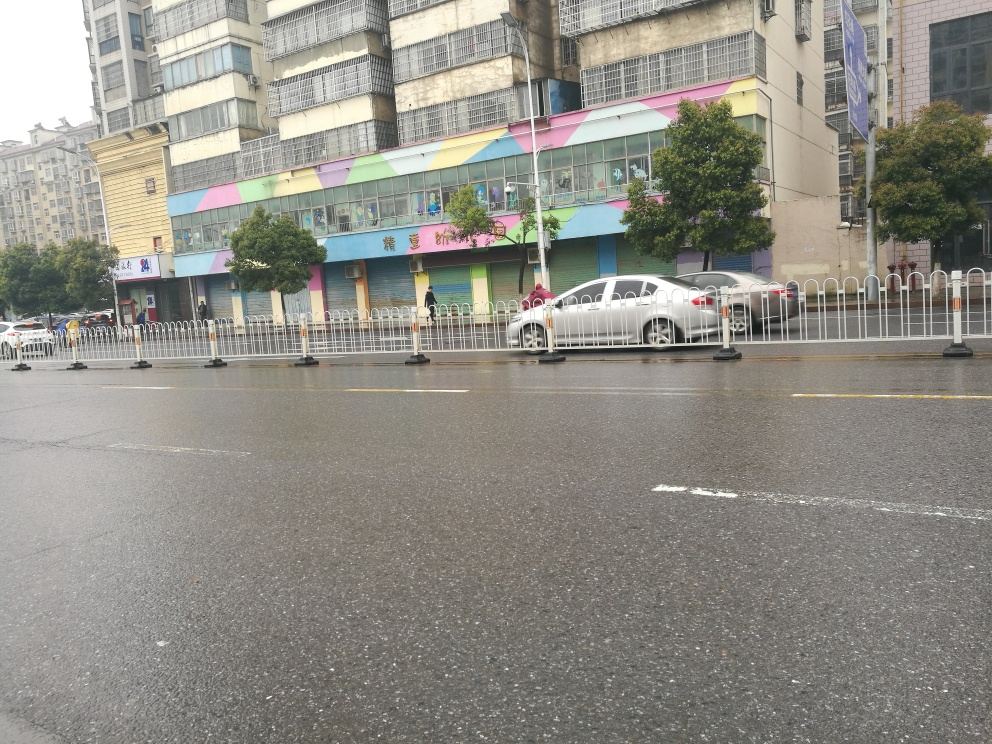Is there any noise present in the image? The image appears to have minimal noise with clear visibility across the scene. While there might be slight pixelation or graininess due to the quality of the camera, these factors do not significantly impair the clarity of the image. 